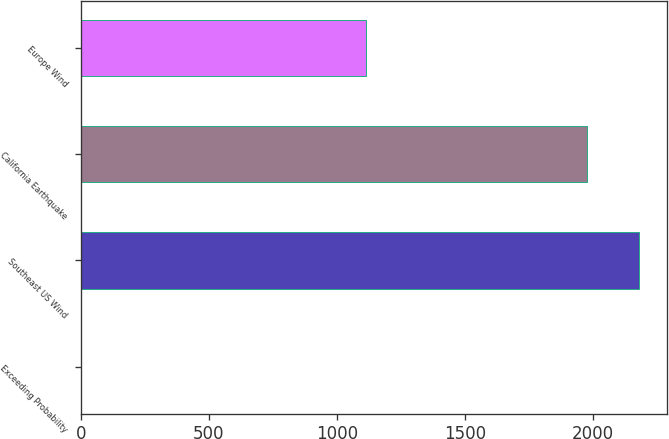Convert chart. <chart><loc_0><loc_0><loc_500><loc_500><bar_chart><fcel>Exceeding Probability<fcel>Southeast US Wind<fcel>California Earthquake<fcel>Europe Wind<nl><fcel>0.1<fcel>2181.19<fcel>1976<fcel>1115<nl></chart> 